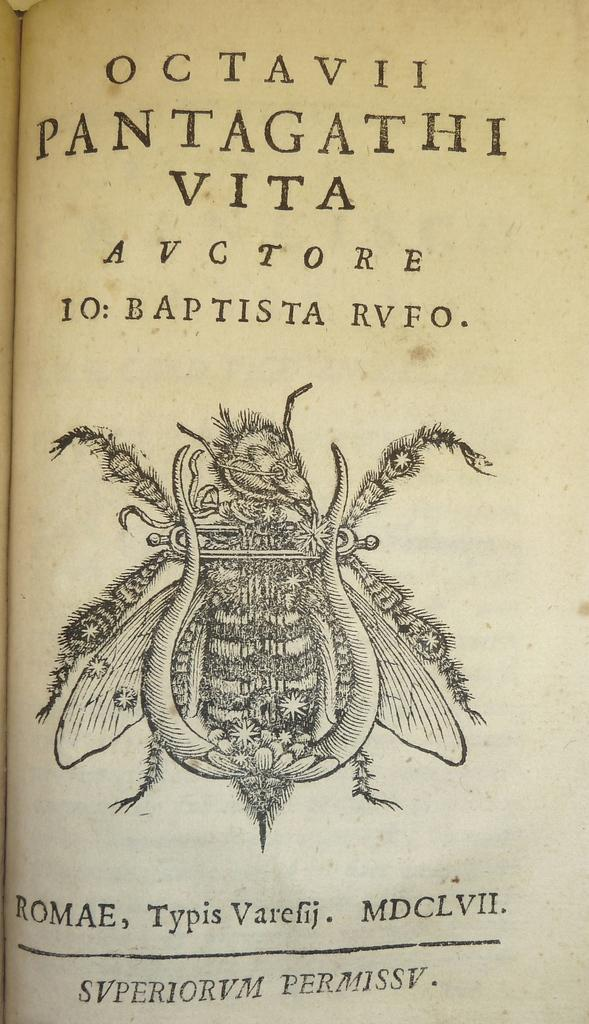What is the main subject of the image? The main subject of the image is a fly. Where is the fly located in the image? The fly is in the middle of the image. What else can be seen in the image besides the fly? There is text at the top and bottom of the image. What type of berry is being used to attract the dinosaurs in the image? There are no berries or dinosaurs present in the image; it features a fly and text. 